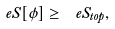Convert formula to latex. <formula><loc_0><loc_0><loc_500><loc_500>\ e S [ \phi ] \geq \ e S _ { t o p } ,</formula> 